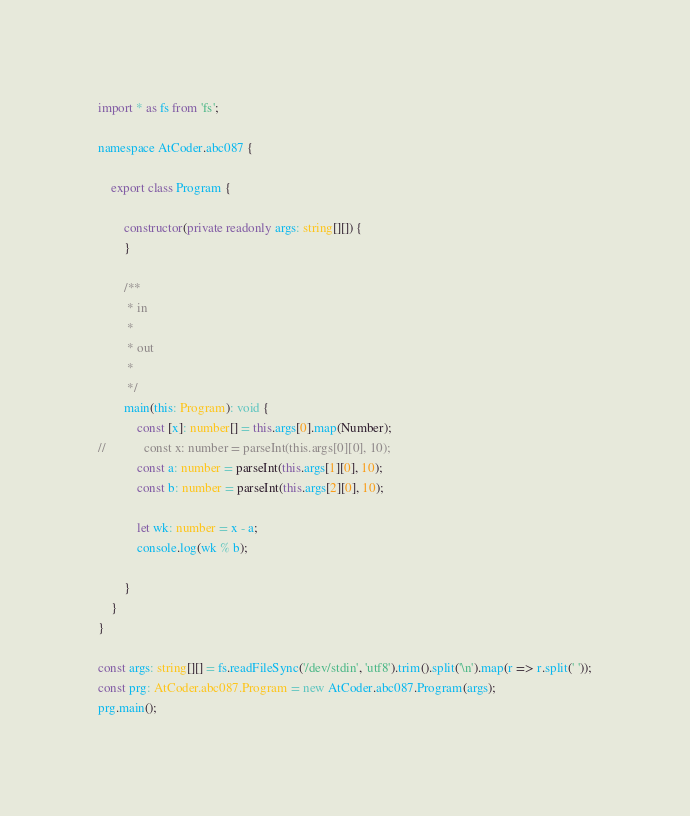Convert code to text. <code><loc_0><loc_0><loc_500><loc_500><_TypeScript_>import * as fs from 'fs';

namespace AtCoder.abc087 {

    export class Program {

        constructor(private readonly args: string[][]) {
        }

        /**
         * in
         *
         * out
         *
         */
        main(this: Program): void {
            const [x]: number[] = this.args[0].map(Number);
//            const x: number = parseInt(this.args[0][0], 10);
            const a: number = parseInt(this.args[1][0], 10);
            const b: number = parseInt(this.args[2][0], 10);

            let wk: number = x - a;
            console.log(wk % b);

        }
    }
}

const args: string[][] = fs.readFileSync('/dev/stdin', 'utf8').trim().split('\n').map(r => r.split(' '));
const prg: AtCoder.abc087.Program = new AtCoder.abc087.Program(args);
prg.main();
</code> 